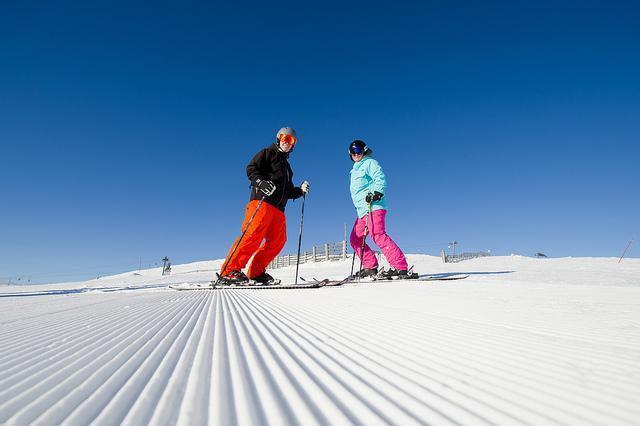How many people are there?
Give a very brief answer. 2. How many frisbees are laying on the ground?
Give a very brief answer. 0. 